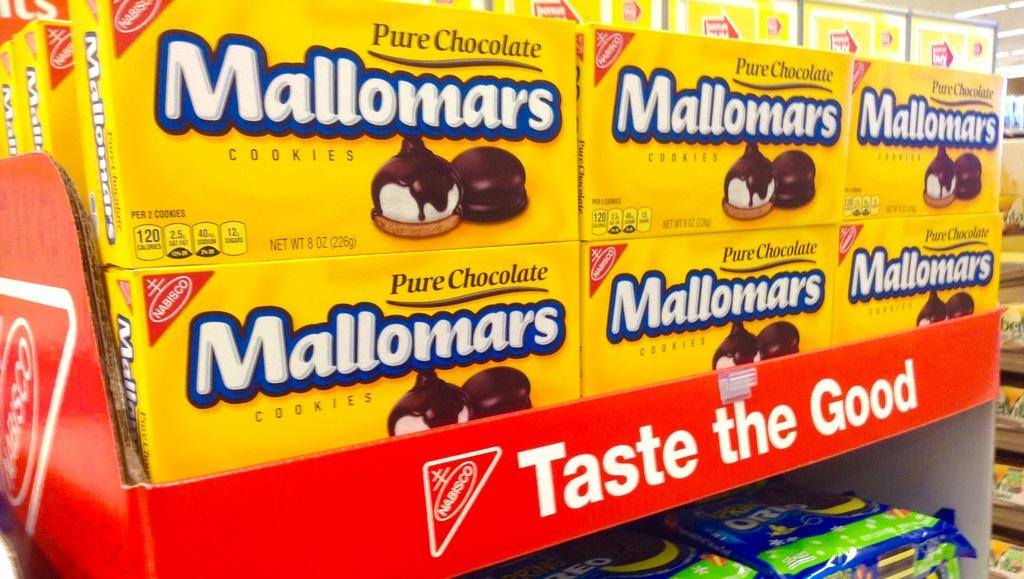What type of product is shown in the image? The image shows chocolate cookies boxes. Where are the boxes located? The boxes are in a store. What type of locket can be seen on the dress in the image? There is no dress or locket present in the image; it features chocolate cookies boxes in a store. How many pizzas are visible in the image? There are no pizzas present in the image. 